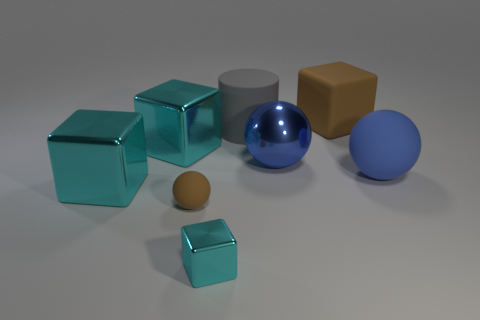How many cyan cubes must be subtracted to get 1 cyan cubes? 2 Subtract all purple spheres. How many cyan blocks are left? 3 Subtract 1 blocks. How many blocks are left? 3 Add 1 tiny red matte cylinders. How many objects exist? 9 Subtract all cylinders. How many objects are left? 7 Add 2 shiny objects. How many shiny objects exist? 6 Subtract 0 cyan cylinders. How many objects are left? 8 Subtract all small rubber objects. Subtract all blue metal cylinders. How many objects are left? 7 Add 3 small metal things. How many small metal things are left? 4 